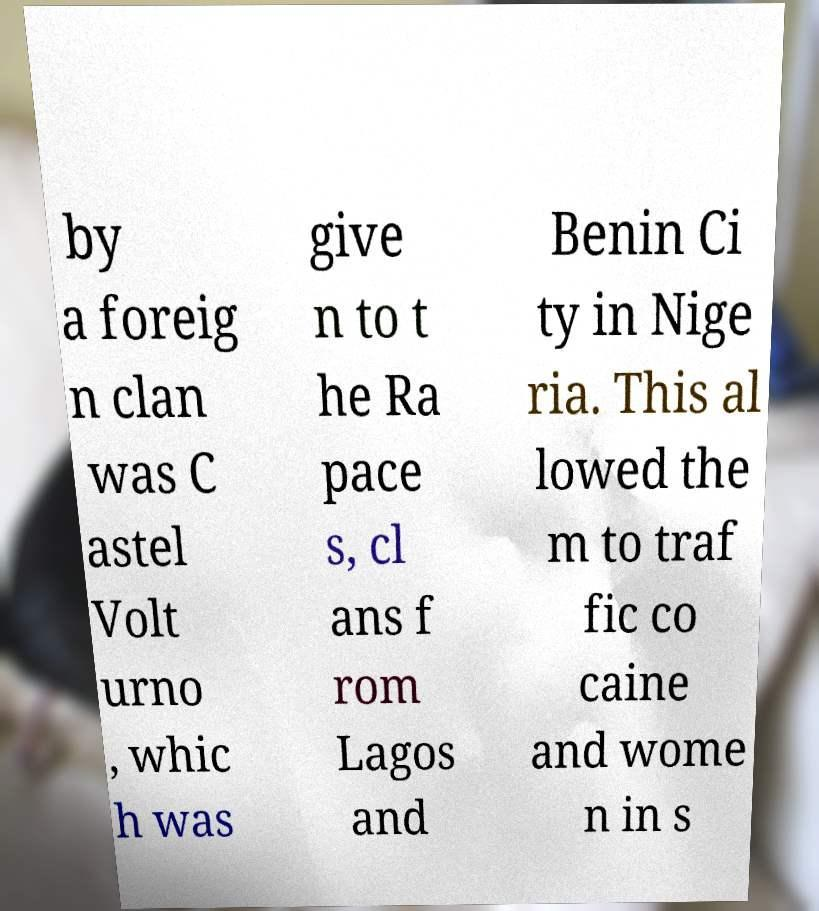Could you extract and type out the text from this image? by a foreig n clan was C astel Volt urno , whic h was give n to t he Ra pace s, cl ans f rom Lagos and Benin Ci ty in Nige ria. This al lowed the m to traf fic co caine and wome n in s 